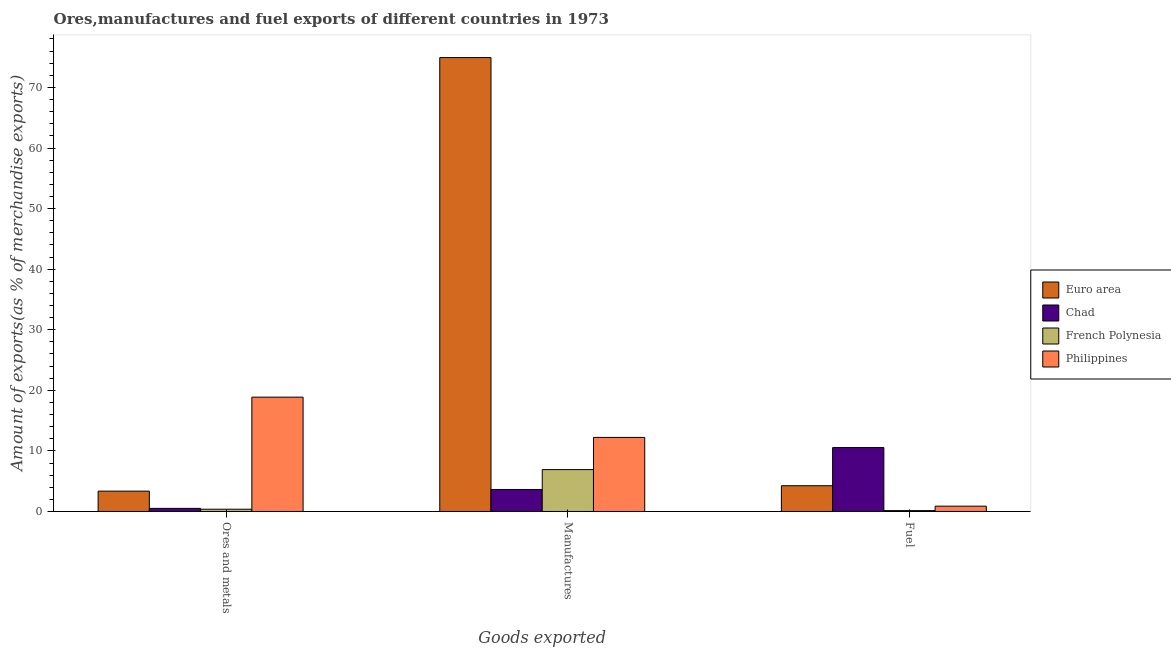How many different coloured bars are there?
Ensure brevity in your answer.  4. What is the label of the 3rd group of bars from the left?
Ensure brevity in your answer.  Fuel. What is the percentage of manufactures exports in Philippines?
Provide a succinct answer. 12.23. Across all countries, what is the maximum percentage of ores and metals exports?
Ensure brevity in your answer.  18.87. Across all countries, what is the minimum percentage of ores and metals exports?
Provide a short and direct response. 0.38. In which country was the percentage of fuel exports maximum?
Offer a very short reply. Chad. In which country was the percentage of manufactures exports minimum?
Provide a short and direct response. Chad. What is the total percentage of fuel exports in the graph?
Offer a terse response. 15.83. What is the difference between the percentage of manufactures exports in Philippines and that in Euro area?
Provide a short and direct response. -62.7. What is the difference between the percentage of manufactures exports in Euro area and the percentage of fuel exports in Chad?
Offer a very short reply. 64.38. What is the average percentage of ores and metals exports per country?
Give a very brief answer. 5.78. What is the difference between the percentage of manufactures exports and percentage of ores and metals exports in Chad?
Offer a terse response. 3.12. What is the ratio of the percentage of manufactures exports in Philippines to that in Chad?
Keep it short and to the point. 3.37. Is the difference between the percentage of ores and metals exports in Chad and Euro area greater than the difference between the percentage of fuel exports in Chad and Euro area?
Ensure brevity in your answer.  No. What is the difference between the highest and the second highest percentage of ores and metals exports?
Your answer should be very brief. 15.51. What is the difference between the highest and the lowest percentage of fuel exports?
Ensure brevity in your answer.  10.41. What does the 2nd bar from the left in Manufactures represents?
Keep it short and to the point. Chad. Is it the case that in every country, the sum of the percentage of ores and metals exports and percentage of manufactures exports is greater than the percentage of fuel exports?
Ensure brevity in your answer.  No. How many bars are there?
Provide a short and direct response. 12. How many countries are there in the graph?
Offer a very short reply. 4. Are the values on the major ticks of Y-axis written in scientific E-notation?
Keep it short and to the point. No. Does the graph contain any zero values?
Keep it short and to the point. No. Does the graph contain grids?
Keep it short and to the point. No. What is the title of the graph?
Your answer should be compact. Ores,manufactures and fuel exports of different countries in 1973. What is the label or title of the X-axis?
Provide a short and direct response. Goods exported. What is the label or title of the Y-axis?
Ensure brevity in your answer.  Amount of exports(as % of merchandise exports). What is the Amount of exports(as % of merchandise exports) of Euro area in Ores and metals?
Provide a succinct answer. 3.36. What is the Amount of exports(as % of merchandise exports) in Chad in Ores and metals?
Ensure brevity in your answer.  0.51. What is the Amount of exports(as % of merchandise exports) of French Polynesia in Ores and metals?
Your answer should be compact. 0.38. What is the Amount of exports(as % of merchandise exports) of Philippines in Ores and metals?
Give a very brief answer. 18.87. What is the Amount of exports(as % of merchandise exports) in Euro area in Manufactures?
Offer a terse response. 74.93. What is the Amount of exports(as % of merchandise exports) in Chad in Manufactures?
Give a very brief answer. 3.63. What is the Amount of exports(as % of merchandise exports) of French Polynesia in Manufactures?
Your response must be concise. 6.91. What is the Amount of exports(as % of merchandise exports) in Philippines in Manufactures?
Your answer should be very brief. 12.23. What is the Amount of exports(as % of merchandise exports) in Euro area in Fuel?
Provide a short and direct response. 4.25. What is the Amount of exports(as % of merchandise exports) in Chad in Fuel?
Make the answer very short. 10.55. What is the Amount of exports(as % of merchandise exports) of French Polynesia in Fuel?
Your answer should be compact. 0.14. What is the Amount of exports(as % of merchandise exports) in Philippines in Fuel?
Provide a succinct answer. 0.88. Across all Goods exported, what is the maximum Amount of exports(as % of merchandise exports) of Euro area?
Make the answer very short. 74.93. Across all Goods exported, what is the maximum Amount of exports(as % of merchandise exports) in Chad?
Give a very brief answer. 10.55. Across all Goods exported, what is the maximum Amount of exports(as % of merchandise exports) of French Polynesia?
Give a very brief answer. 6.91. Across all Goods exported, what is the maximum Amount of exports(as % of merchandise exports) of Philippines?
Keep it short and to the point. 18.87. Across all Goods exported, what is the minimum Amount of exports(as % of merchandise exports) of Euro area?
Your response must be concise. 3.36. Across all Goods exported, what is the minimum Amount of exports(as % of merchandise exports) in Chad?
Offer a very short reply. 0.51. Across all Goods exported, what is the minimum Amount of exports(as % of merchandise exports) in French Polynesia?
Offer a terse response. 0.14. Across all Goods exported, what is the minimum Amount of exports(as % of merchandise exports) in Philippines?
Offer a terse response. 0.88. What is the total Amount of exports(as % of merchandise exports) in Euro area in the graph?
Provide a succinct answer. 82.54. What is the total Amount of exports(as % of merchandise exports) of Chad in the graph?
Offer a terse response. 14.7. What is the total Amount of exports(as % of merchandise exports) of French Polynesia in the graph?
Keep it short and to the point. 7.43. What is the total Amount of exports(as % of merchandise exports) in Philippines in the graph?
Your response must be concise. 31.98. What is the difference between the Amount of exports(as % of merchandise exports) of Euro area in Ores and metals and that in Manufactures?
Your response must be concise. -71.57. What is the difference between the Amount of exports(as % of merchandise exports) in Chad in Ores and metals and that in Manufactures?
Your answer should be very brief. -3.12. What is the difference between the Amount of exports(as % of merchandise exports) in French Polynesia in Ores and metals and that in Manufactures?
Make the answer very short. -6.54. What is the difference between the Amount of exports(as % of merchandise exports) of Philippines in Ores and metals and that in Manufactures?
Offer a terse response. 6.65. What is the difference between the Amount of exports(as % of merchandise exports) in Euro area in Ores and metals and that in Fuel?
Offer a very short reply. -0.89. What is the difference between the Amount of exports(as % of merchandise exports) in Chad in Ores and metals and that in Fuel?
Offer a terse response. -10.04. What is the difference between the Amount of exports(as % of merchandise exports) of French Polynesia in Ores and metals and that in Fuel?
Provide a succinct answer. 0.23. What is the difference between the Amount of exports(as % of merchandise exports) of Philippines in Ores and metals and that in Fuel?
Your answer should be compact. 18. What is the difference between the Amount of exports(as % of merchandise exports) of Euro area in Manufactures and that in Fuel?
Offer a terse response. 70.68. What is the difference between the Amount of exports(as % of merchandise exports) in Chad in Manufactures and that in Fuel?
Provide a succinct answer. -6.92. What is the difference between the Amount of exports(as % of merchandise exports) of French Polynesia in Manufactures and that in Fuel?
Offer a terse response. 6.77. What is the difference between the Amount of exports(as % of merchandise exports) of Philippines in Manufactures and that in Fuel?
Ensure brevity in your answer.  11.35. What is the difference between the Amount of exports(as % of merchandise exports) in Euro area in Ores and metals and the Amount of exports(as % of merchandise exports) in Chad in Manufactures?
Give a very brief answer. -0.27. What is the difference between the Amount of exports(as % of merchandise exports) in Euro area in Ores and metals and the Amount of exports(as % of merchandise exports) in French Polynesia in Manufactures?
Give a very brief answer. -3.55. What is the difference between the Amount of exports(as % of merchandise exports) of Euro area in Ores and metals and the Amount of exports(as % of merchandise exports) of Philippines in Manufactures?
Provide a short and direct response. -8.87. What is the difference between the Amount of exports(as % of merchandise exports) of Chad in Ores and metals and the Amount of exports(as % of merchandise exports) of French Polynesia in Manufactures?
Make the answer very short. -6.4. What is the difference between the Amount of exports(as % of merchandise exports) of Chad in Ores and metals and the Amount of exports(as % of merchandise exports) of Philippines in Manufactures?
Make the answer very short. -11.71. What is the difference between the Amount of exports(as % of merchandise exports) of French Polynesia in Ores and metals and the Amount of exports(as % of merchandise exports) of Philippines in Manufactures?
Give a very brief answer. -11.85. What is the difference between the Amount of exports(as % of merchandise exports) in Euro area in Ores and metals and the Amount of exports(as % of merchandise exports) in Chad in Fuel?
Your answer should be very brief. -7.19. What is the difference between the Amount of exports(as % of merchandise exports) in Euro area in Ores and metals and the Amount of exports(as % of merchandise exports) in French Polynesia in Fuel?
Ensure brevity in your answer.  3.22. What is the difference between the Amount of exports(as % of merchandise exports) in Euro area in Ores and metals and the Amount of exports(as % of merchandise exports) in Philippines in Fuel?
Provide a succinct answer. 2.48. What is the difference between the Amount of exports(as % of merchandise exports) in Chad in Ores and metals and the Amount of exports(as % of merchandise exports) in French Polynesia in Fuel?
Keep it short and to the point. 0.37. What is the difference between the Amount of exports(as % of merchandise exports) of Chad in Ores and metals and the Amount of exports(as % of merchandise exports) of Philippines in Fuel?
Your answer should be compact. -0.37. What is the difference between the Amount of exports(as % of merchandise exports) in French Polynesia in Ores and metals and the Amount of exports(as % of merchandise exports) in Philippines in Fuel?
Provide a short and direct response. -0.5. What is the difference between the Amount of exports(as % of merchandise exports) of Euro area in Manufactures and the Amount of exports(as % of merchandise exports) of Chad in Fuel?
Keep it short and to the point. 64.38. What is the difference between the Amount of exports(as % of merchandise exports) of Euro area in Manufactures and the Amount of exports(as % of merchandise exports) of French Polynesia in Fuel?
Give a very brief answer. 74.79. What is the difference between the Amount of exports(as % of merchandise exports) in Euro area in Manufactures and the Amount of exports(as % of merchandise exports) in Philippines in Fuel?
Keep it short and to the point. 74.05. What is the difference between the Amount of exports(as % of merchandise exports) in Chad in Manufactures and the Amount of exports(as % of merchandise exports) in French Polynesia in Fuel?
Your answer should be very brief. 3.49. What is the difference between the Amount of exports(as % of merchandise exports) of Chad in Manufactures and the Amount of exports(as % of merchandise exports) of Philippines in Fuel?
Offer a very short reply. 2.75. What is the difference between the Amount of exports(as % of merchandise exports) of French Polynesia in Manufactures and the Amount of exports(as % of merchandise exports) of Philippines in Fuel?
Your answer should be compact. 6.03. What is the average Amount of exports(as % of merchandise exports) in Euro area per Goods exported?
Give a very brief answer. 27.51. What is the average Amount of exports(as % of merchandise exports) of Chad per Goods exported?
Offer a terse response. 4.9. What is the average Amount of exports(as % of merchandise exports) of French Polynesia per Goods exported?
Your answer should be very brief. 2.48. What is the average Amount of exports(as % of merchandise exports) of Philippines per Goods exported?
Provide a succinct answer. 10.66. What is the difference between the Amount of exports(as % of merchandise exports) in Euro area and Amount of exports(as % of merchandise exports) in Chad in Ores and metals?
Give a very brief answer. 2.85. What is the difference between the Amount of exports(as % of merchandise exports) in Euro area and Amount of exports(as % of merchandise exports) in French Polynesia in Ores and metals?
Offer a very short reply. 2.98. What is the difference between the Amount of exports(as % of merchandise exports) in Euro area and Amount of exports(as % of merchandise exports) in Philippines in Ores and metals?
Give a very brief answer. -15.51. What is the difference between the Amount of exports(as % of merchandise exports) of Chad and Amount of exports(as % of merchandise exports) of French Polynesia in Ores and metals?
Provide a short and direct response. 0.14. What is the difference between the Amount of exports(as % of merchandise exports) in Chad and Amount of exports(as % of merchandise exports) in Philippines in Ores and metals?
Your answer should be compact. -18.36. What is the difference between the Amount of exports(as % of merchandise exports) in French Polynesia and Amount of exports(as % of merchandise exports) in Philippines in Ores and metals?
Provide a short and direct response. -18.5. What is the difference between the Amount of exports(as % of merchandise exports) in Euro area and Amount of exports(as % of merchandise exports) in Chad in Manufactures?
Give a very brief answer. 71.3. What is the difference between the Amount of exports(as % of merchandise exports) in Euro area and Amount of exports(as % of merchandise exports) in French Polynesia in Manufactures?
Make the answer very short. 68.02. What is the difference between the Amount of exports(as % of merchandise exports) of Euro area and Amount of exports(as % of merchandise exports) of Philippines in Manufactures?
Offer a terse response. 62.7. What is the difference between the Amount of exports(as % of merchandise exports) in Chad and Amount of exports(as % of merchandise exports) in French Polynesia in Manufactures?
Keep it short and to the point. -3.28. What is the difference between the Amount of exports(as % of merchandise exports) in Chad and Amount of exports(as % of merchandise exports) in Philippines in Manufactures?
Keep it short and to the point. -8.59. What is the difference between the Amount of exports(as % of merchandise exports) in French Polynesia and Amount of exports(as % of merchandise exports) in Philippines in Manufactures?
Your answer should be very brief. -5.31. What is the difference between the Amount of exports(as % of merchandise exports) of Euro area and Amount of exports(as % of merchandise exports) of Chad in Fuel?
Provide a succinct answer. -6.3. What is the difference between the Amount of exports(as % of merchandise exports) of Euro area and Amount of exports(as % of merchandise exports) of French Polynesia in Fuel?
Offer a very short reply. 4.11. What is the difference between the Amount of exports(as % of merchandise exports) in Euro area and Amount of exports(as % of merchandise exports) in Philippines in Fuel?
Keep it short and to the point. 3.37. What is the difference between the Amount of exports(as % of merchandise exports) in Chad and Amount of exports(as % of merchandise exports) in French Polynesia in Fuel?
Provide a succinct answer. 10.41. What is the difference between the Amount of exports(as % of merchandise exports) of Chad and Amount of exports(as % of merchandise exports) of Philippines in Fuel?
Offer a very short reply. 9.67. What is the difference between the Amount of exports(as % of merchandise exports) in French Polynesia and Amount of exports(as % of merchandise exports) in Philippines in Fuel?
Give a very brief answer. -0.73. What is the ratio of the Amount of exports(as % of merchandise exports) in Euro area in Ores and metals to that in Manufactures?
Provide a short and direct response. 0.04. What is the ratio of the Amount of exports(as % of merchandise exports) in Chad in Ores and metals to that in Manufactures?
Make the answer very short. 0.14. What is the ratio of the Amount of exports(as % of merchandise exports) in French Polynesia in Ores and metals to that in Manufactures?
Ensure brevity in your answer.  0.05. What is the ratio of the Amount of exports(as % of merchandise exports) in Philippines in Ores and metals to that in Manufactures?
Provide a succinct answer. 1.54. What is the ratio of the Amount of exports(as % of merchandise exports) in Euro area in Ores and metals to that in Fuel?
Your answer should be very brief. 0.79. What is the ratio of the Amount of exports(as % of merchandise exports) in Chad in Ores and metals to that in Fuel?
Offer a very short reply. 0.05. What is the ratio of the Amount of exports(as % of merchandise exports) of French Polynesia in Ores and metals to that in Fuel?
Provide a succinct answer. 2.6. What is the ratio of the Amount of exports(as % of merchandise exports) in Philippines in Ores and metals to that in Fuel?
Provide a short and direct response. 21.47. What is the ratio of the Amount of exports(as % of merchandise exports) of Euro area in Manufactures to that in Fuel?
Provide a short and direct response. 17.62. What is the ratio of the Amount of exports(as % of merchandise exports) in Chad in Manufactures to that in Fuel?
Give a very brief answer. 0.34. What is the ratio of the Amount of exports(as % of merchandise exports) in French Polynesia in Manufactures to that in Fuel?
Provide a short and direct response. 47.88. What is the ratio of the Amount of exports(as % of merchandise exports) in Philippines in Manufactures to that in Fuel?
Keep it short and to the point. 13.91. What is the difference between the highest and the second highest Amount of exports(as % of merchandise exports) of Euro area?
Provide a succinct answer. 70.68. What is the difference between the highest and the second highest Amount of exports(as % of merchandise exports) of Chad?
Your answer should be very brief. 6.92. What is the difference between the highest and the second highest Amount of exports(as % of merchandise exports) of French Polynesia?
Offer a very short reply. 6.54. What is the difference between the highest and the second highest Amount of exports(as % of merchandise exports) of Philippines?
Your response must be concise. 6.65. What is the difference between the highest and the lowest Amount of exports(as % of merchandise exports) in Euro area?
Your answer should be compact. 71.57. What is the difference between the highest and the lowest Amount of exports(as % of merchandise exports) in Chad?
Your answer should be compact. 10.04. What is the difference between the highest and the lowest Amount of exports(as % of merchandise exports) of French Polynesia?
Your answer should be compact. 6.77. What is the difference between the highest and the lowest Amount of exports(as % of merchandise exports) of Philippines?
Give a very brief answer. 18. 